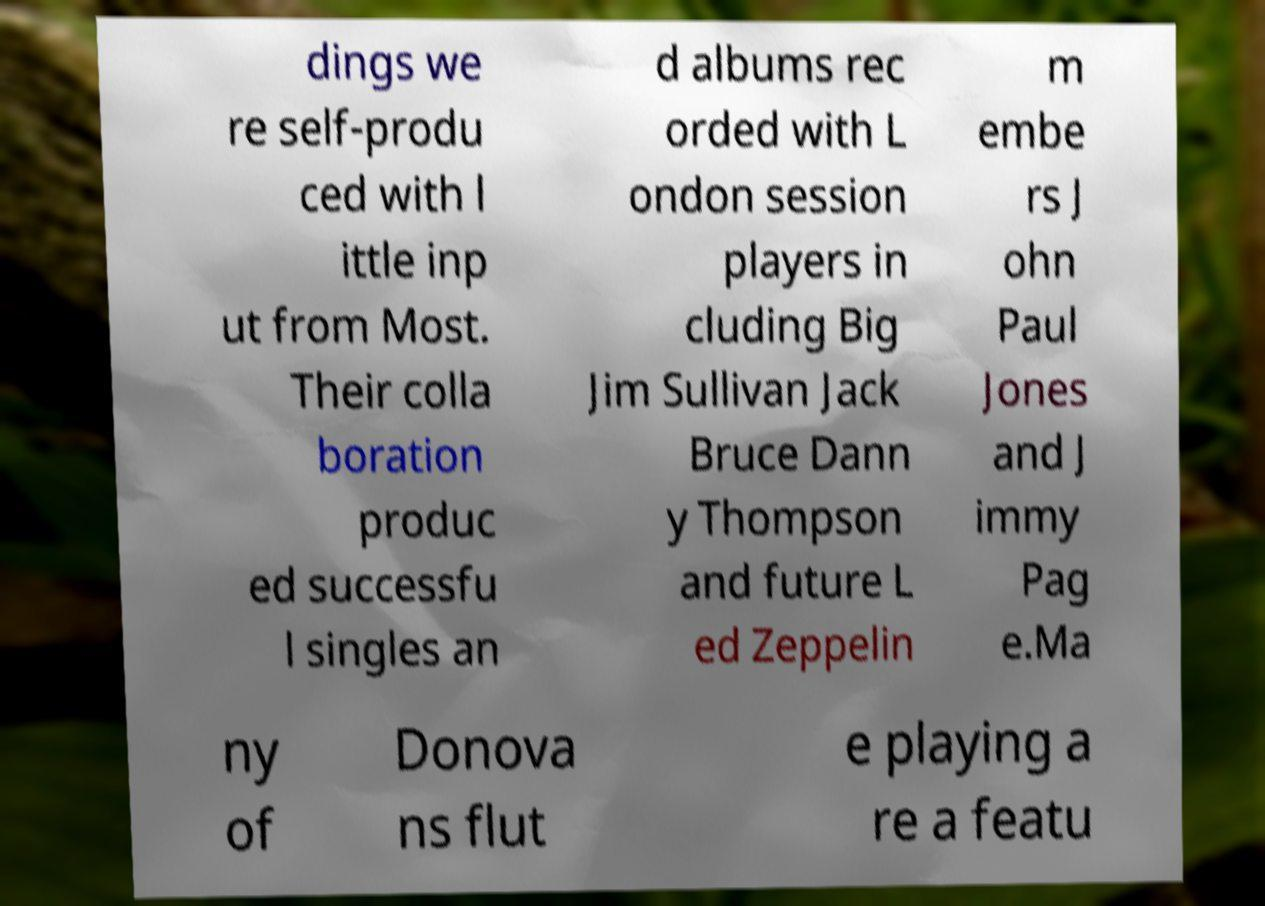Could you assist in decoding the text presented in this image and type it out clearly? dings we re self-produ ced with l ittle inp ut from Most. Their colla boration produc ed successfu l singles an d albums rec orded with L ondon session players in cluding Big Jim Sullivan Jack Bruce Dann y Thompson and future L ed Zeppelin m embe rs J ohn Paul Jones and J immy Pag e.Ma ny of Donova ns flut e playing a re a featu 